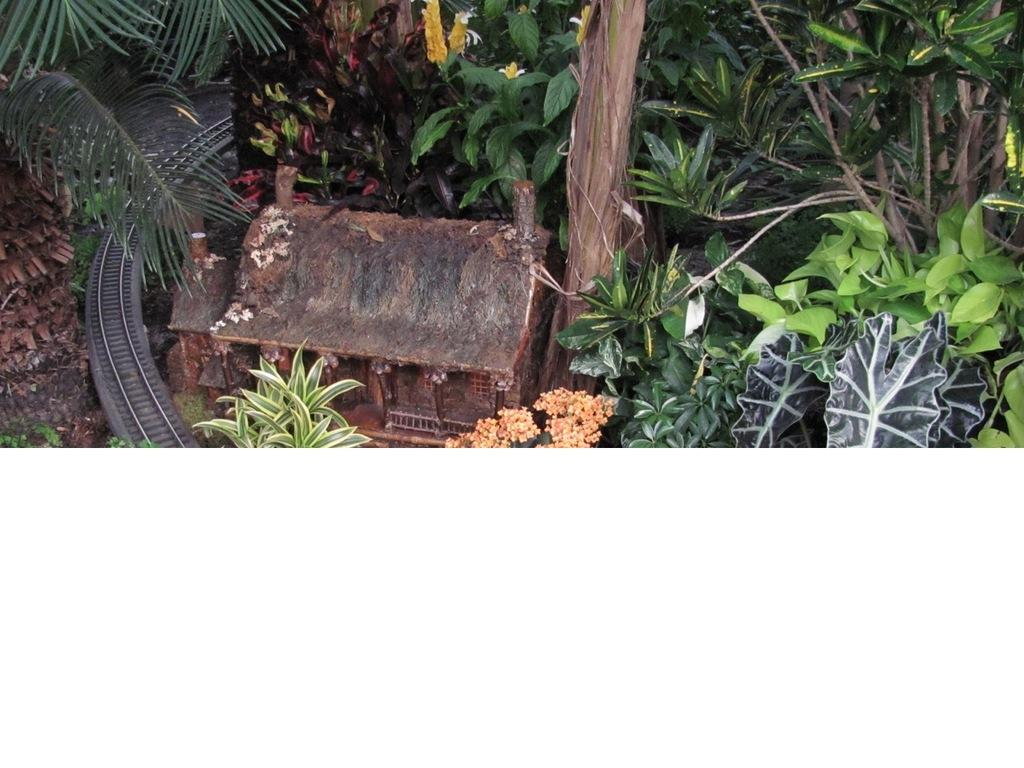What celestial bodies are depicted in the image? There are planets in the image. What type of structure is present in the image? There is a miniature house in the image. What feature can be seen in the image that might be used for transportation or movement? There is a track in the image. How many cherries are hanging from the planets in the image? There are no cherries present in the image; it features planets and a miniature house. What type of material is burning in the image? There is no material burning in the image; it does not depict any fires or flames. 